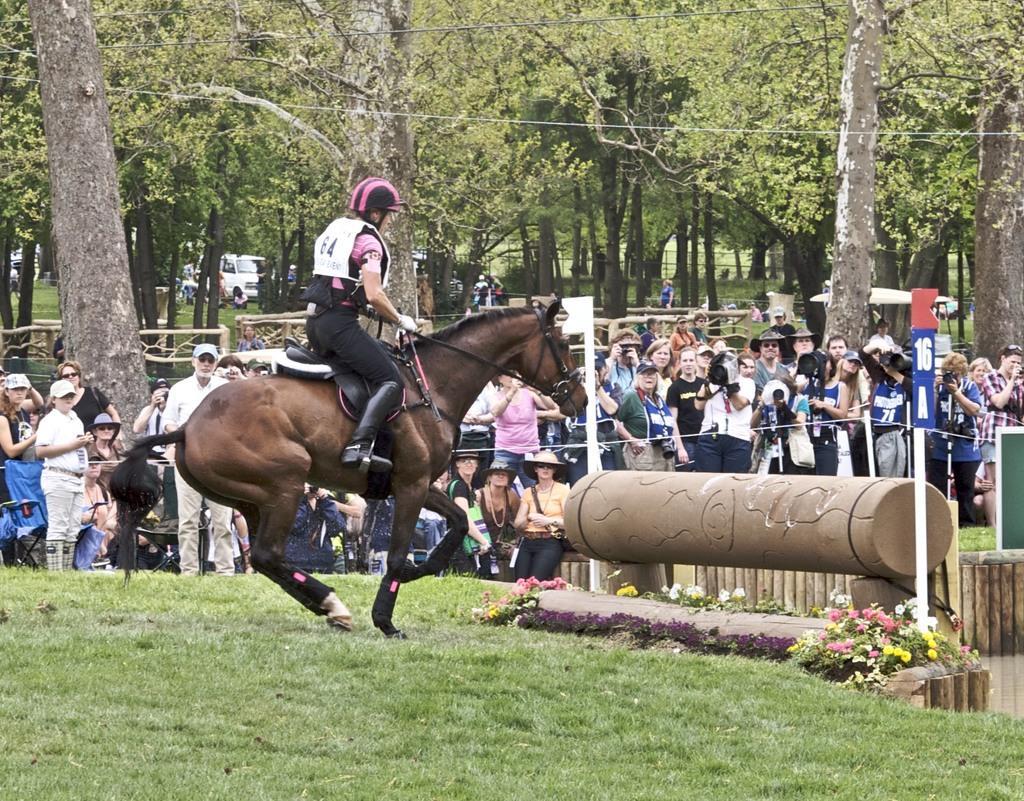Please provide a concise description of this image. In this picture there is a man who is riding a horse. At the bottom we can see the grass, beside that we can see flowers on the plant. On the right we can see the group of persons were standing near to the fencing and some people holding camera. In the background we can see vehicles, persons, fencing, trees, plants and grass. 